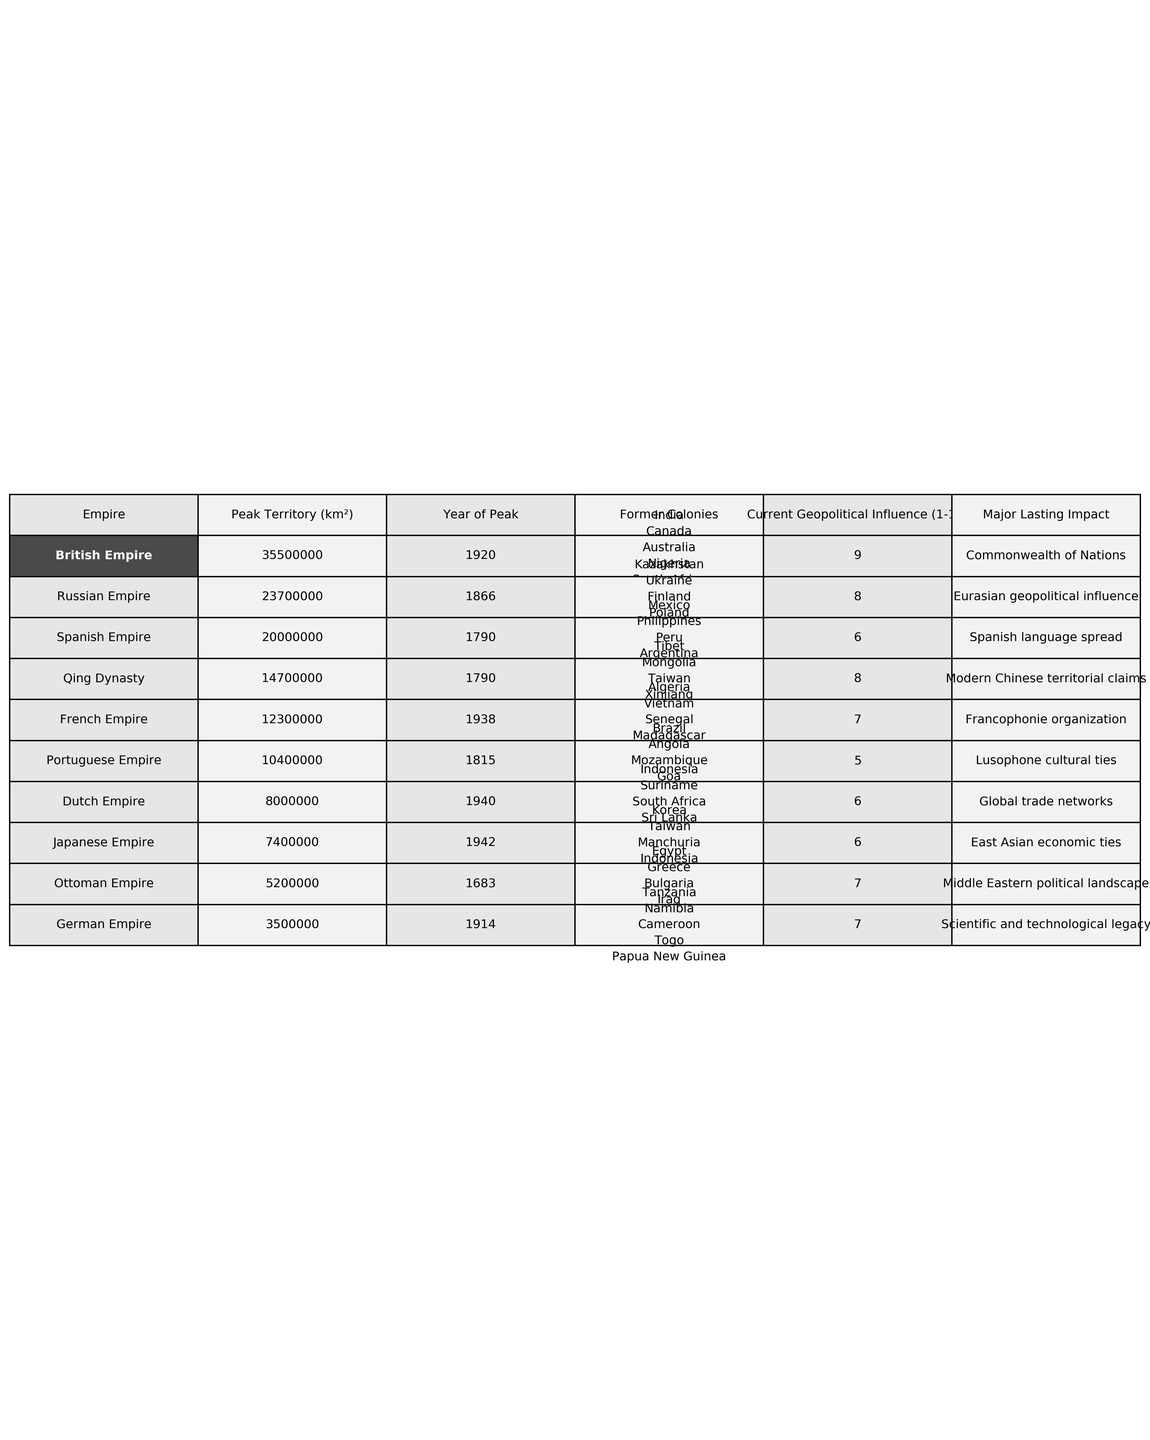What is the peak territory of the British Empire? The table indicates that the peak territory of the British Empire was 35,500,000 km².
Answer: 35,500,000 km² Which empire had the largest peak territory? By comparing the peak territories listed in the table, the British Empire had the largest area at 35,500,000 km².
Answer: British Empire How many former colonies did the French Empire have? The table lists five former colonies for the French Empire: Algeria, Vietnam, Senegal, Madagascar, and Haiti, which totals five colonies.
Answer: 5 Which empire has the highest current geopolitical influence rating? The British Empire has a current geopolitical influence rating of 9, the highest in the table.
Answer: British Empire What is the difference in peak territory between the Spanish Empire and the Portuguese Empire? The Spanish Empire had a peak territory of 20,000,000 km², while the Portuguese Empire had 10,400,000 km². The difference is calculated as 20,000,000 - 10,400,000 = 9,600,000 km².
Answer: 9,600,000 km² Are there any empires with a current geopolitical influence rating of 6? Yes, the Spanish Empire, Dutch Empire, and Japanese Empire all have a current geopolitical influence rating of 6.
Answer: Yes What is the average peak territory of all the empires listed in the table? To find the average, sum the peak territories: 35,500,000 + 20,000,000 + 12,300,000 + 10,400,000 + 8,000,000 + 23,700,000 + 5,200,000 + 14,700,000 + 7,400,000 + 3,500,000 = 137,900,000 km². There are 10 empires, so the average is 137,900,000 km² / 10 = 13,790,000 km².
Answer: 13,790,000 km² Which empire had the last significant influence on the Middle East? The Ottoman Empire is listed as having a lasting impact on the Middle Eastern political landscape, indicating its significant influence.
Answer: Ottoman Empire Was the German Empire more influential than the Portuguese Empire based on the current geopolitical influence ratings? The German Empire has a rating of 7, while the Portuguese Empire has a rating of 5; therefore, the German Empire was more influential.
Answer: Yes How does the lasting impact of the British Empire compare to that of the French Empire? The British Empire's lasting impact is the Commonwealth of Nations, while the French Empire's is the Francophonie organization; both significantly influence their respective regions, but in different contexts.
Answer: Different contexts 